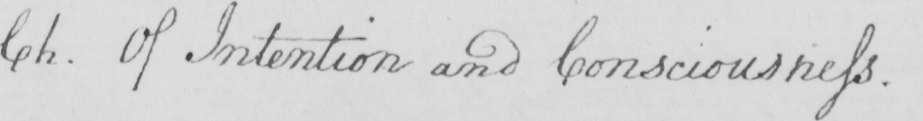Transcribe the text shown in this historical manuscript line. Ch. Of Intention and Consciousness. 